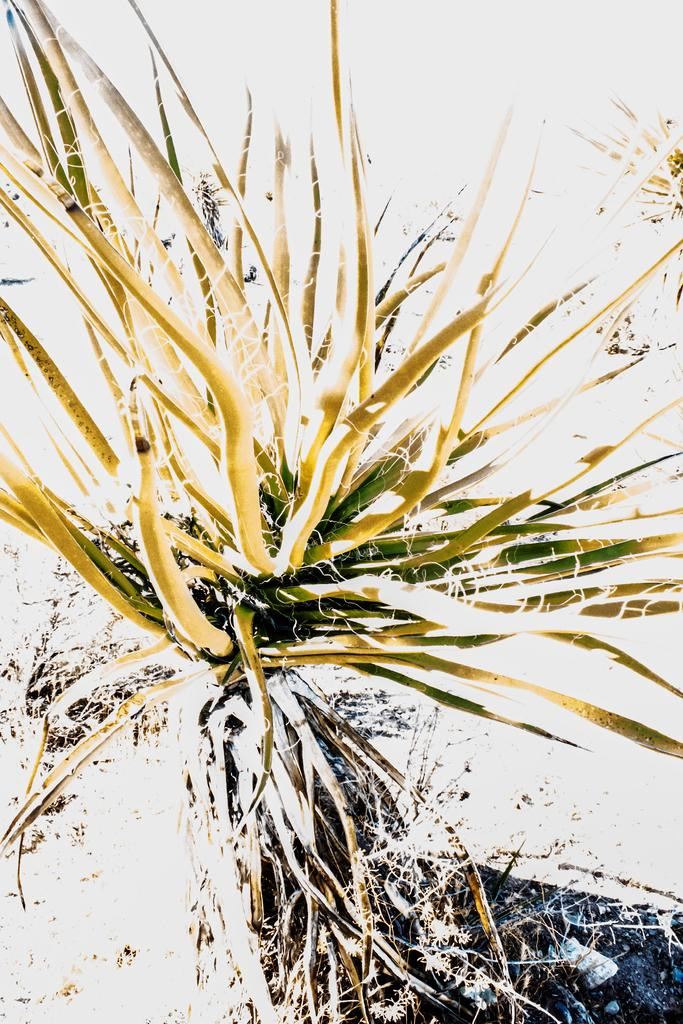What type of living organism can be seen in the image? There is a plant in the image. What is visible at the bottom of the image? The ground is visible at the bottom of the image. What can be found on the ground in the image? Dried stems are present on the ground. Can you see a yak grazing on the plant in the image? There is no yak present in the image. 